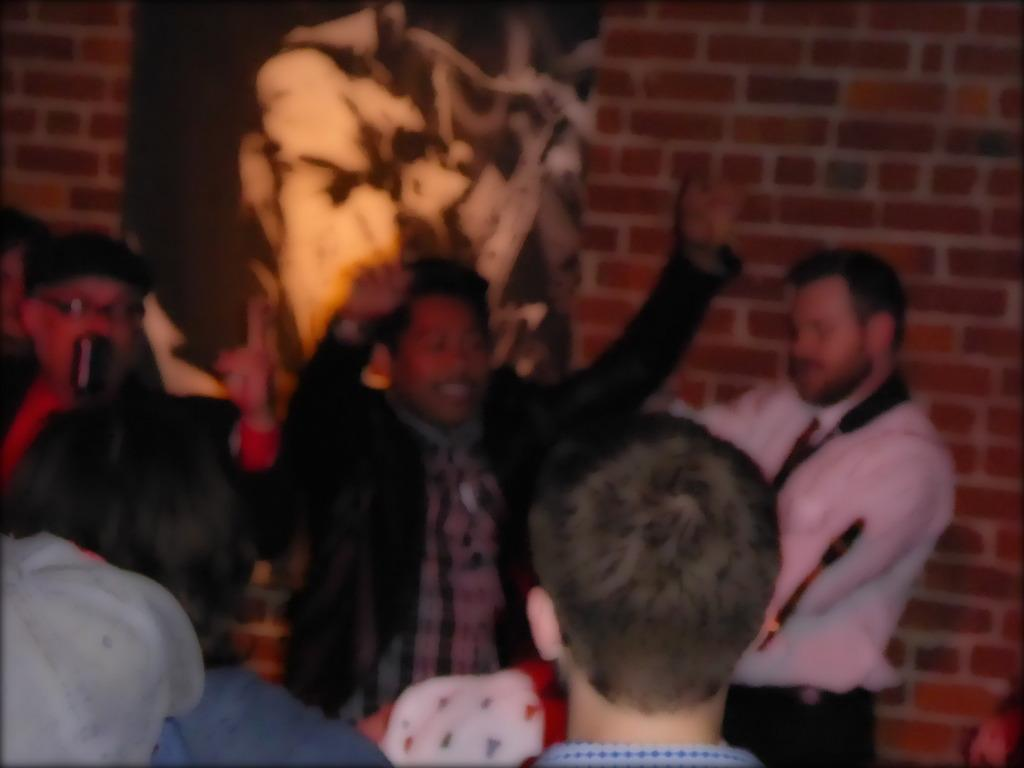What is happening in the foreground of the image? There is a group of people in the foreground of the image, and they are dancing on the floor. What can be seen in the background of the image? There is a wall in the background of the image, and there is a wall painting on the wall. What type of location might the image have been taken in? The image may have been taken in a hall, given the presence of a group of people dancing and a wall with a painting. Can you see a crown on the head of any of the dancers in the image? There is no crown visible on the heads of the dancers in the image. Is the sea visible in the background of the image? The sea is not visible in the background of the image; it features a wall with a painting. 